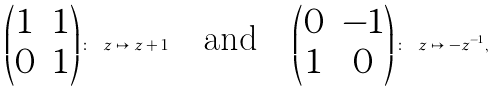Convert formula to latex. <formula><loc_0><loc_0><loc_500><loc_500>\begin{pmatrix} 1 & 1 \\ 0 & 1 \end{pmatrix} \colon \ z \mapsto z + 1 \quad \text {and} \quad \begin{pmatrix} 0 & - 1 \\ 1 & 0 \end{pmatrix} \colon \ z \mapsto - z ^ { - 1 } ,</formula> 